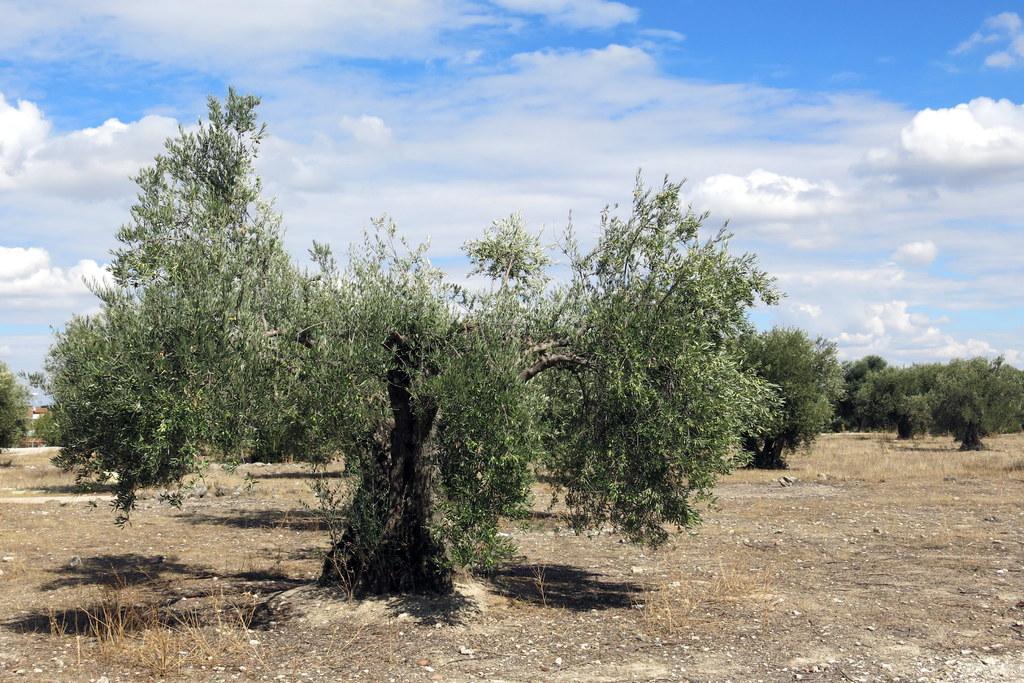Can you describe this image briefly? In this image there are trees in an open ground. 